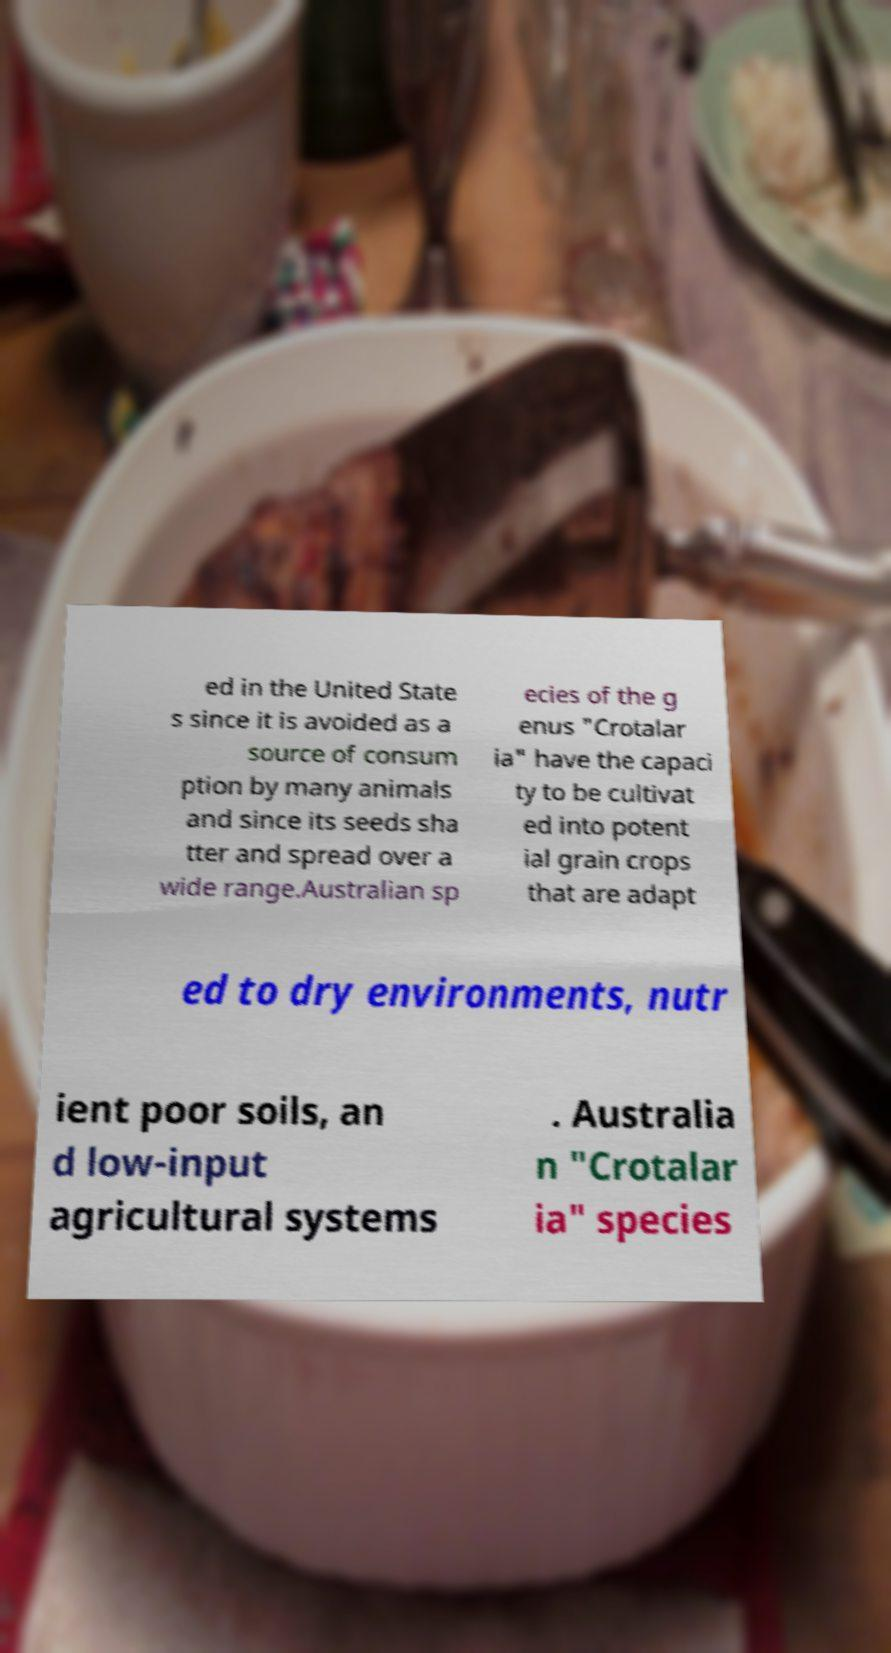Can you accurately transcribe the text from the provided image for me? ed in the United State s since it is avoided as a source of consum ption by many animals and since its seeds sha tter and spread over a wide range.Australian sp ecies of the g enus "Crotalar ia" have the capaci ty to be cultivat ed into potent ial grain crops that are adapt ed to dry environments, nutr ient poor soils, an d low-input agricultural systems . Australia n "Crotalar ia" species 